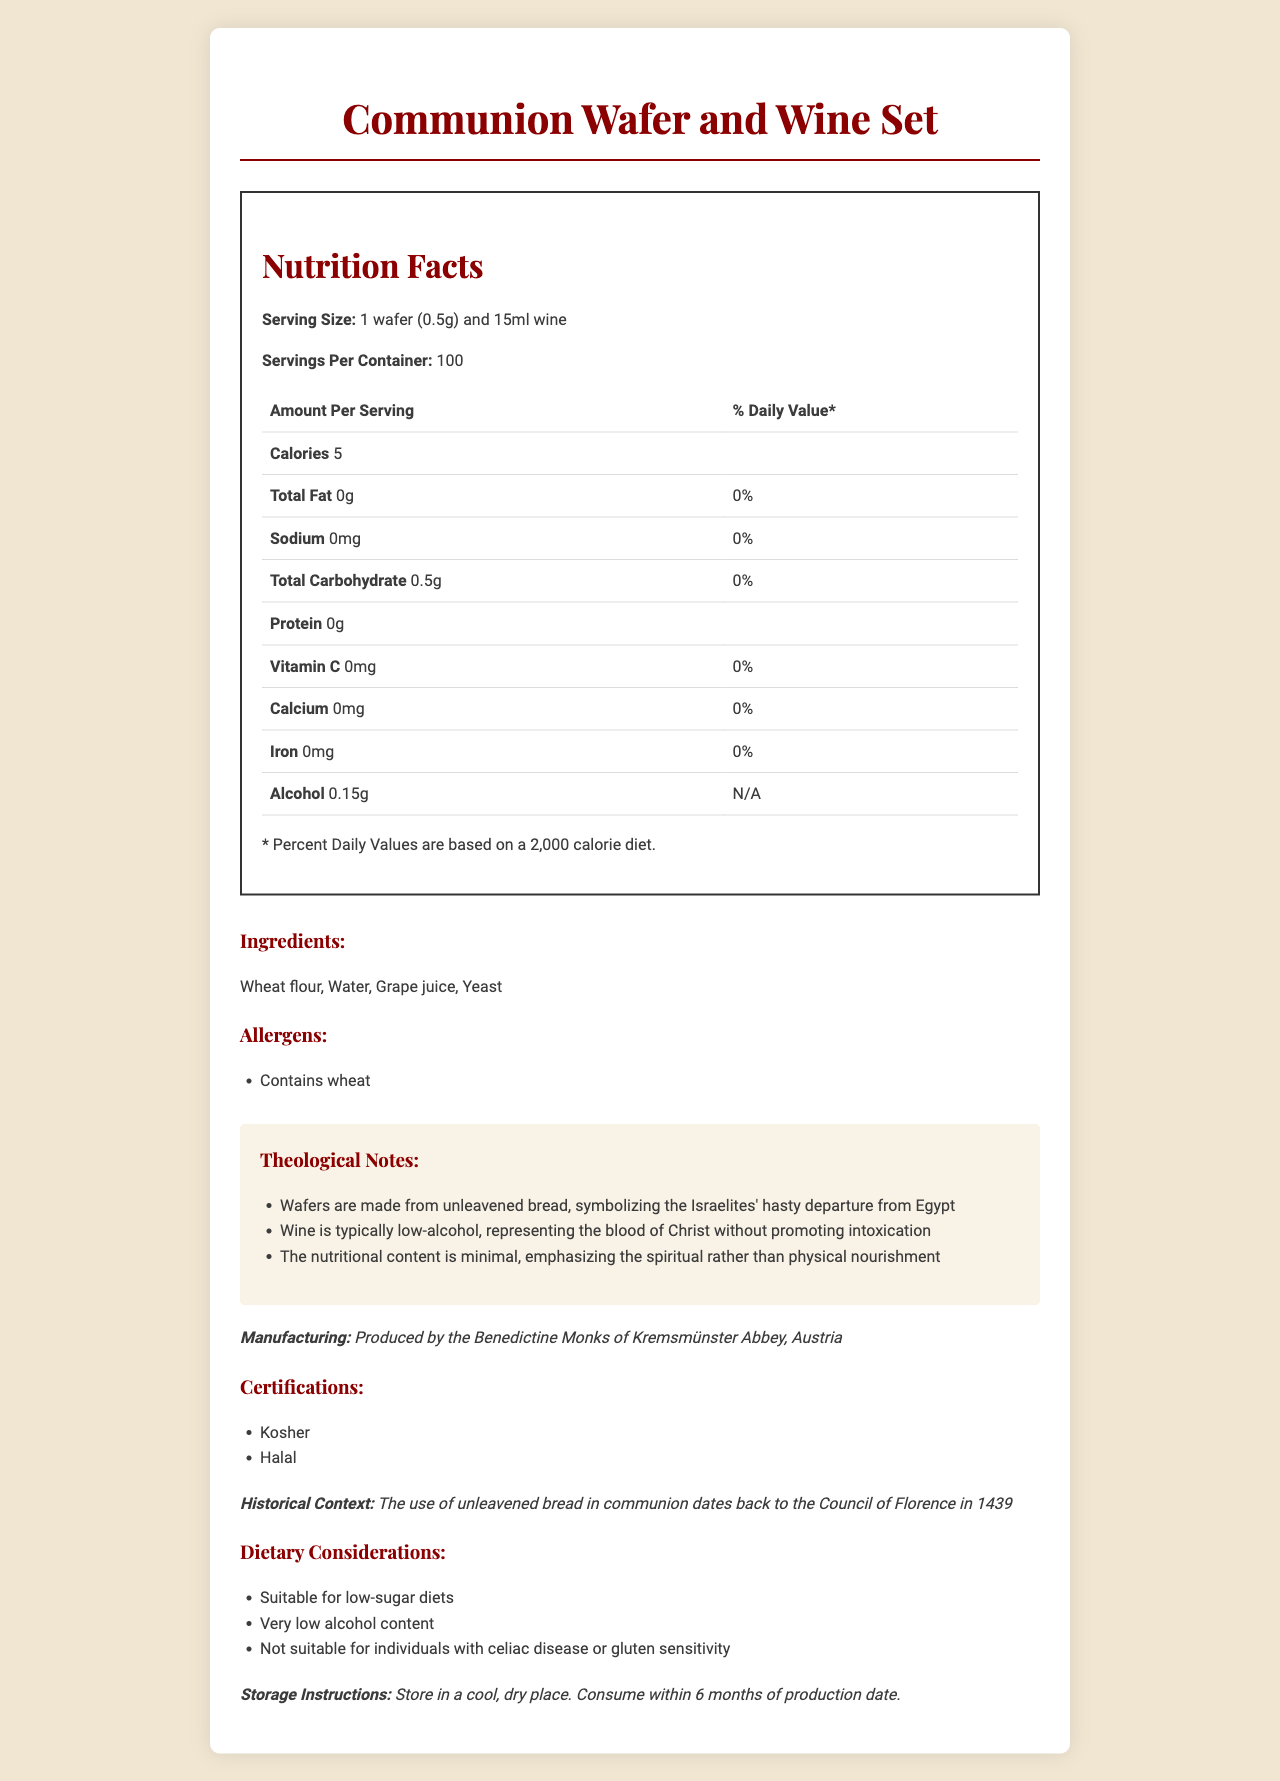what is the serving size of the Communion Wafer and Wine Set? The serving size is specified in the document under the "Nutrition Facts" section.
Answer: 1 wafer (0.5g) and 15ml wine how many servings are there per container? The number of servings per container is given in the "Nutrition Facts" section.
Answer: 100 how many calories are in one serving? The amount of calories per serving is mentioned under "Amount Per Serving" in the "Nutrition Facts" section.
Answer: 5 what is the amount of total fat per serving? The total fat per serving is detailed under "Total Fat" in the "Nutrition Facts" section.
Answer: 0g what are the ingredients of the Communion Wafer and Wine Set? The ingredients are listed in the "Ingredients" section.
Answer: Wheat flour, Water, Grape juice, Yeast what is the amount of alcohol per serving? The amount of alcohol per serving is provided under "Alcohol" in the "Nutrition Facts" section.
Answer: 0.15g how should the Communion Wafer and Wine Set be stored? The storage instructions are given at the end of the document.
Answer: Store in a cool, dry place. Consume within 6 months of production date. is the Communion Wafer and Wine Set suitable for individuals with gluten sensitivity? The dietary considerations section mentions that it is not suitable for individuals with gluten sensitivity.
Answer: No who produces the Communion Wafer and Wine Set? The manufacturing information is provided under the "Manufacturing" section.
Answer: Benedictine Monks of Kremsmünster Abbey, Austria What dietary considerations are mentioned for the Communion Wafer and Wine Set? The dietary considerations are explicitly listed under the "Dietary Considerations" section.
Answer: 1. Suitable for low-sugar diets
2. Very low alcohol content
3. Not suitable for individuals with celiac disease or gluten sensitivity which certifications does the Communion Wafer and Wine Set have?
A. Kashrut
B. Organic
C. Kosher
D. Halal The certifications section includes Kosher and Halal.
Answer: C. Kosher and D. Halal which is a theological note mentioned in the document?
1. Wafers symbolize the body of Christ
2. Wine promotes spiritual intoxication
3. Wine represents the blood of Christ without promoting intoxication The theological notes section specifies that the wine represents the blood of Christ without promoting intoxication.
Answer: 3. Wine represents the blood of Christ without promoting intoxication is the Communion Wafer and Wine Set high in sugar? The dietary considerations section mentions it as suitable for low-sugar diets.
Answer: No summarize the main idea of the document. The document outlines nutritional facts, theological notes, dietary considerations, storage instructions, and manufacturing details for the Communion Wafer and Wine Set.
Answer: The document provides nutritional, theological, and practical information about the Communion Wafer and Wine Set, emphasizing its low sugar and alcohol content, its symbolic significance, and usage guidelines. what was the Council of Florence's role in the use of unleavened bread in communion? The document references the historical context but does not explicitly describe the Council of Florence's role.
Answer: I don't know 